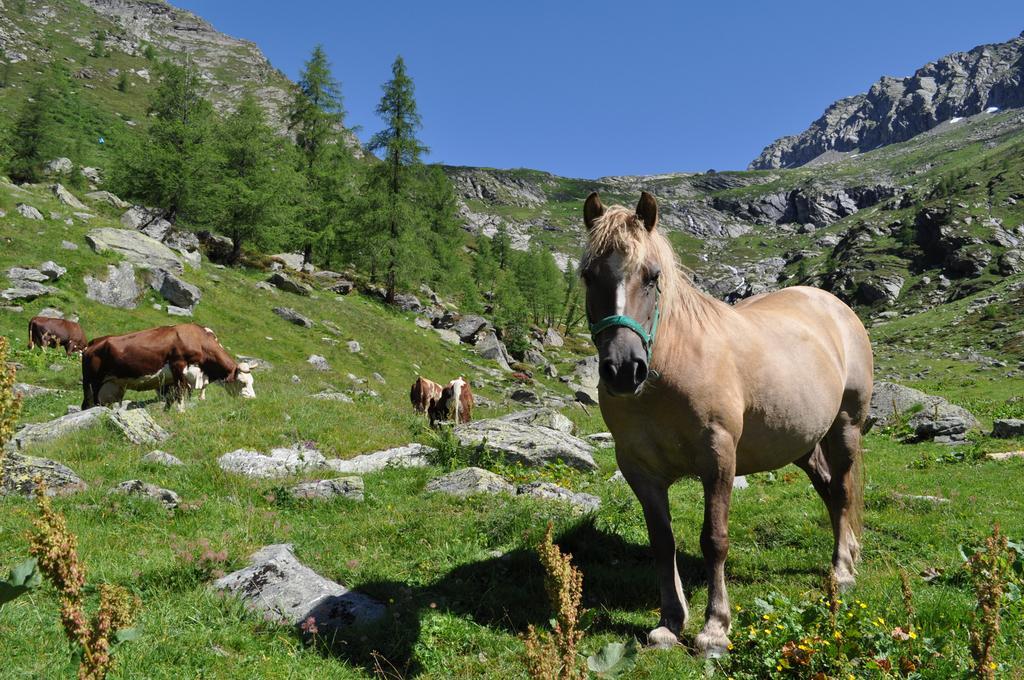Can you describe this image briefly? In this picture we can see few animals, grass and rocks, in the background we can find few trees and hills. 